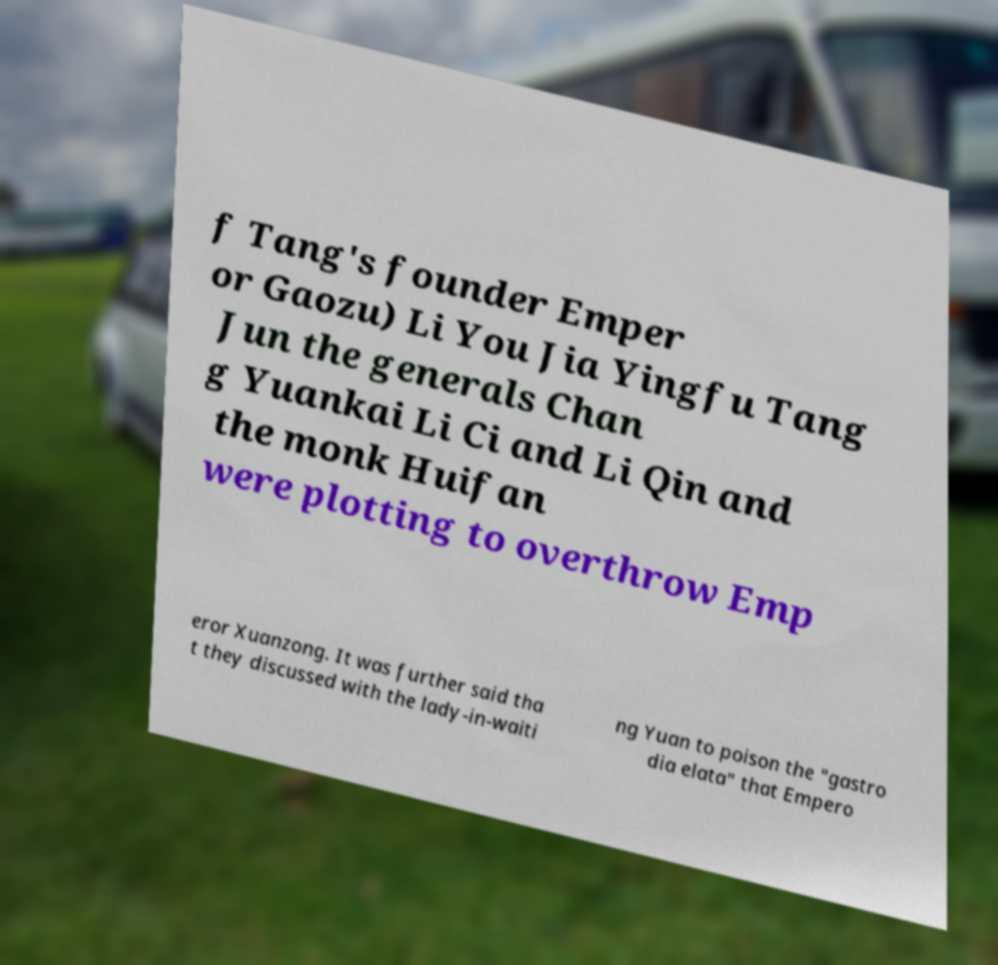Please read and relay the text visible in this image. What does it say? f Tang's founder Emper or Gaozu) Li You Jia Yingfu Tang Jun the generals Chan g Yuankai Li Ci and Li Qin and the monk Huifan were plotting to overthrow Emp eror Xuanzong. It was further said tha t they discussed with the lady-in-waiti ng Yuan to poison the "gastro dia elata" that Empero 